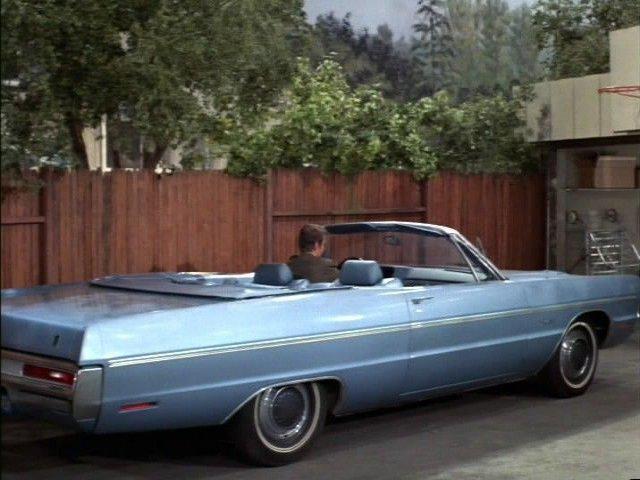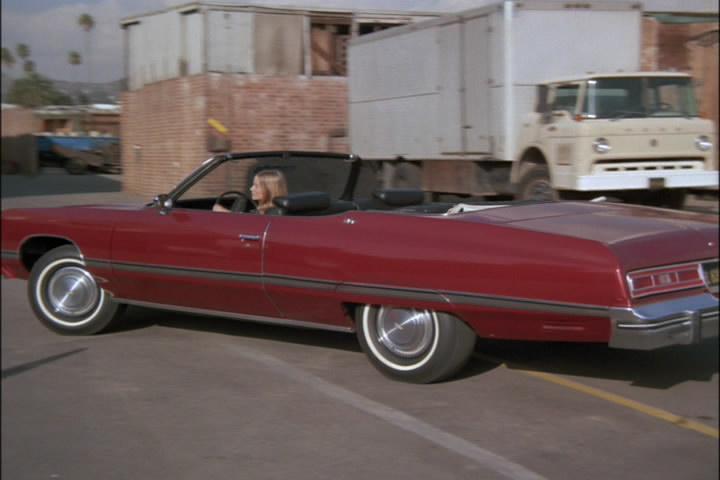The first image is the image on the left, the second image is the image on the right. For the images shown, is this caption "There is one convertible driving down the road facing left." true? Answer yes or no. Yes. The first image is the image on the left, the second image is the image on the right. Evaluate the accuracy of this statement regarding the images: "There is a convertible in each photo with it's top down". Is it true? Answer yes or no. Yes. 